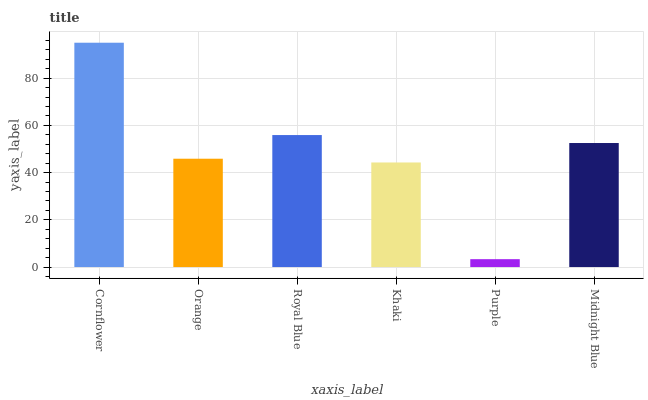Is Purple the minimum?
Answer yes or no. Yes. Is Cornflower the maximum?
Answer yes or no. Yes. Is Orange the minimum?
Answer yes or no. No. Is Orange the maximum?
Answer yes or no. No. Is Cornflower greater than Orange?
Answer yes or no. Yes. Is Orange less than Cornflower?
Answer yes or no. Yes. Is Orange greater than Cornflower?
Answer yes or no. No. Is Cornflower less than Orange?
Answer yes or no. No. Is Midnight Blue the high median?
Answer yes or no. Yes. Is Orange the low median?
Answer yes or no. Yes. Is Cornflower the high median?
Answer yes or no. No. Is Royal Blue the low median?
Answer yes or no. No. 